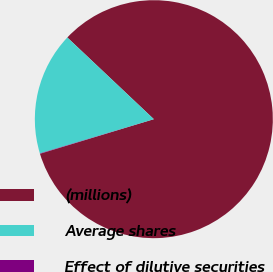<chart> <loc_0><loc_0><loc_500><loc_500><pie_chart><fcel>(millions)<fcel>Average shares<fcel>Effect of dilutive securities<nl><fcel>83.26%<fcel>16.69%<fcel>0.05%<nl></chart> 